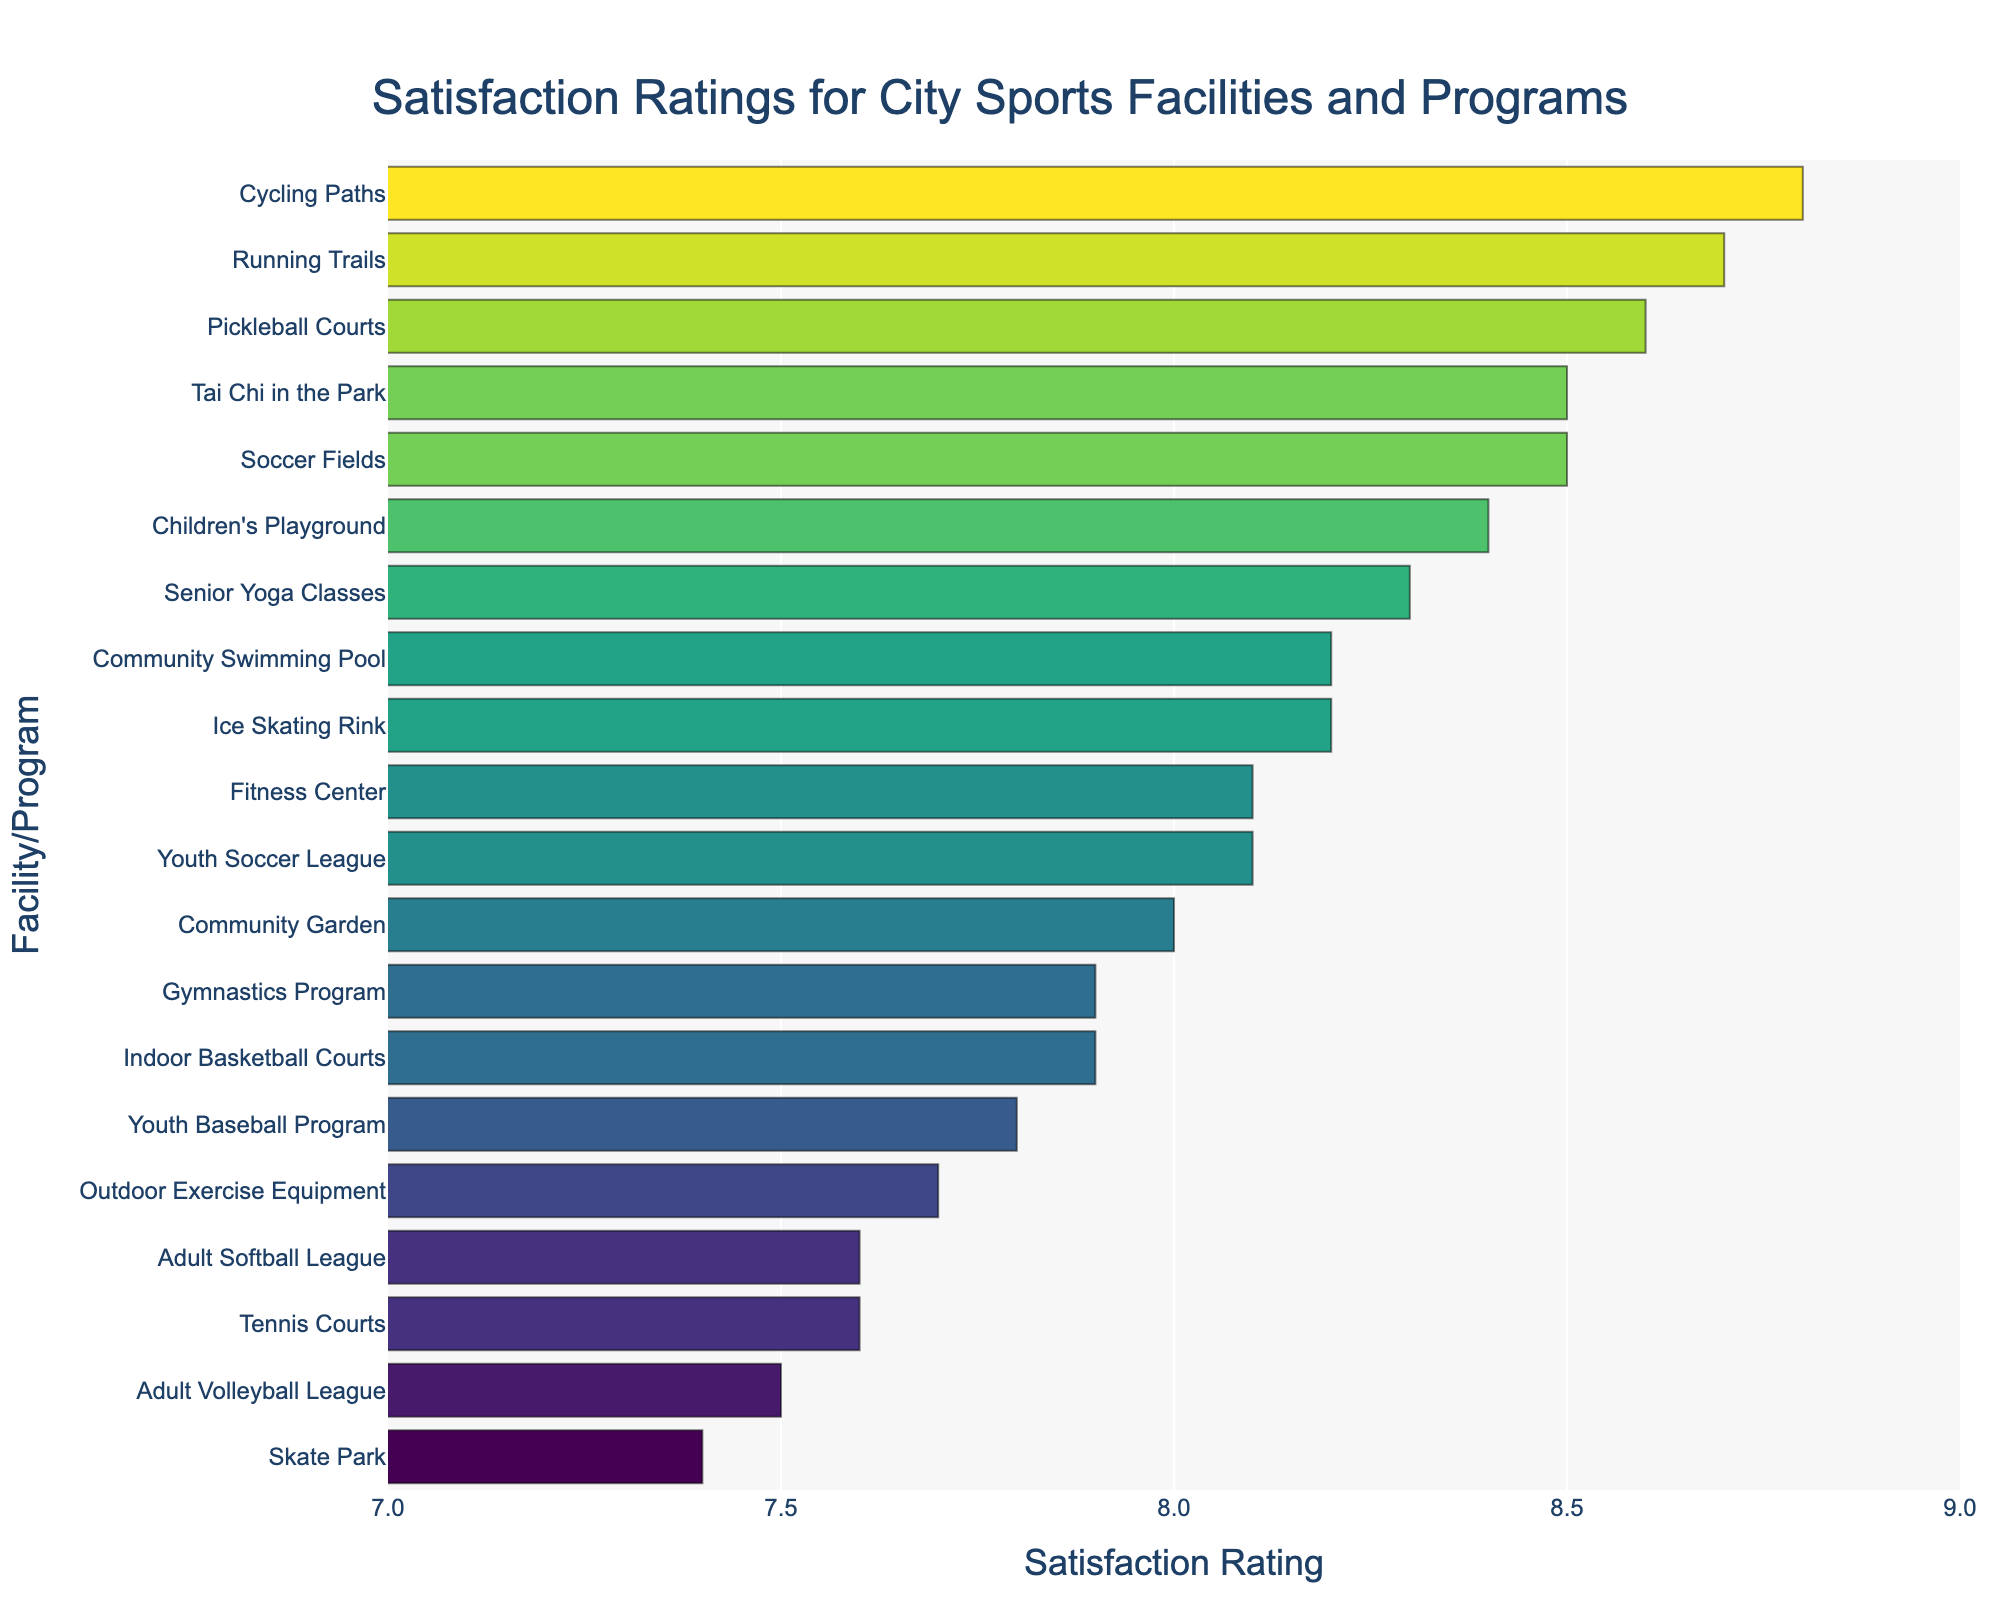Which facility has the highest satisfaction rating? The facility with the highest satisfaction rating will have the longest bar in the chart that extends farthest to the right.
Answer: Cycling Paths Which facility has the lowest satisfaction rating? The facility with the lowest satisfaction rating will have the shortest bar in the chart that extends the least to the right.
Answer: Skate Park Which has a higher satisfaction rating, Community Swimming Pool or Youth Baseball Program? Compare the lengths of the bars corresponding to Community Swimming Pool and Youth Baseball Program. The longer bar belongs to the facility with the higher rating.
Answer: Community Swimming Pool What is the difference in satisfaction rating between Running Trails and Skate Park? Find the lengths of the bars for Running Trails and Skate Park, and subtract the Skate Park rating from the Running Trails rating. Running Trails has a rating of 8.7, and Skate Park has a rating of 7.4. The difference is 8.7 - 7.4.
Answer: 1.3 What is the average satisfaction rating of the Community Garden, Senior Yoga Classes, and Ice Skating Rink? Add the satisfaction ratings for Community Garden (8.0), Senior Yoga Classes (8.3), and Ice Skating Rink (8.2), then divide by 3 to find the average. (8.0 + 8.3 + 8.2) / 3 = 24.5 / 3.
Answer: 8.167 Which has a higher satisfaction rating: Youth Soccer League or Adult Volleyball League? Compare the lengths of the bars for Youth Soccer League and Adult Volleyball League. The longer bar indicates the higher rating.
Answer: Youth Soccer League What is the total satisfaction rating for Tennis Courts and Children’s Playground combined? Add the satisfaction ratings for Tennis Courts (7.6) and Children’s Playground (8.4) to get the total. 7.6 + 8.4 = 16.
Answer: 16 Which facilities have a satisfaction rating of exactly 8.2? Identify the bars that extend to the 8.2 mark on the x-axis.
Answer: Community Swimming Pool, Ice Skating Rink What is the range of satisfaction ratings across all facilities? Find the difference between the highest and lowest satisfaction ratings. The highest rating is 8.8 (Cycling Paths) and the lowest is 7.4 (Skate Park). The range is 8.8 - 7.4.
Answer: 1.4 